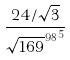<formula> <loc_0><loc_0><loc_500><loc_500>\frac { 2 4 / \sqrt { 3 } } { { \sqrt { 1 6 9 } ^ { 9 8 } } ^ { 5 } }</formula> 